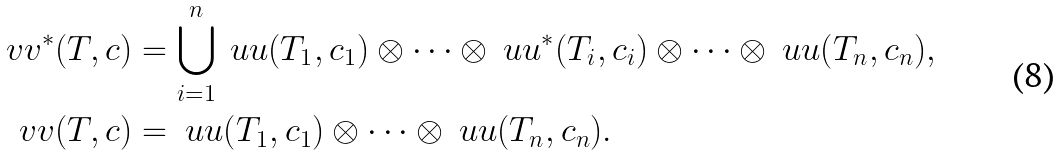Convert formula to latex. <formula><loc_0><loc_0><loc_500><loc_500>\ v v ^ { * } ( T , c ) & = \bigcup _ { i = 1 } ^ { n } \ u u ( T _ { 1 } , c _ { 1 } ) \otimes \cdots \otimes \ u u ^ { * } ( T _ { i } , c _ { i } ) \otimes \cdots \otimes \ u u ( T _ { n } , c _ { n } ) , \\ \ v v ( T , c ) & = \ u u ( T _ { 1 } , c _ { 1 } ) \otimes \cdots \otimes \ u u ( T _ { n } , c _ { n } ) .</formula> 